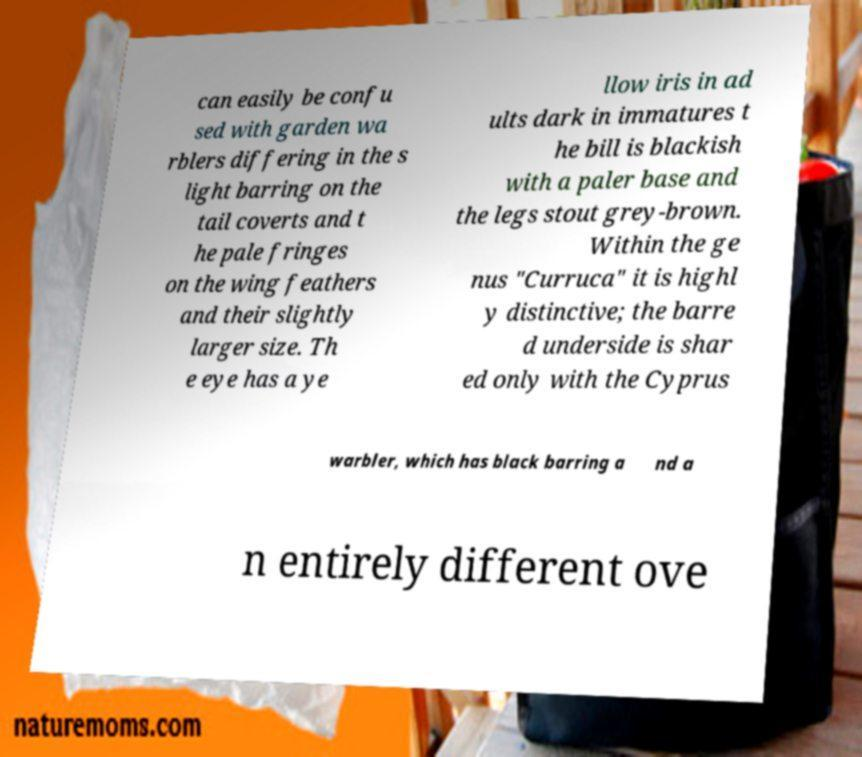Could you extract and type out the text from this image? can easily be confu sed with garden wa rblers differing in the s light barring on the tail coverts and t he pale fringes on the wing feathers and their slightly larger size. Th e eye has a ye llow iris in ad ults dark in immatures t he bill is blackish with a paler base and the legs stout grey-brown. Within the ge nus "Curruca" it is highl y distinctive; the barre d underside is shar ed only with the Cyprus warbler, which has black barring a nd a n entirely different ove 